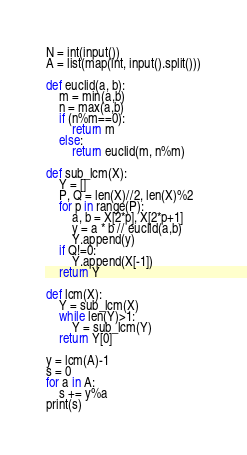Convert code to text. <code><loc_0><loc_0><loc_500><loc_500><_Python_>N = int(input())
A = list(map(int, input().split()))

def euclid(a, b):
    m = min(a,b)
    n = max(a,b)
    if (n%m==0):
        return m
    else:
        return euclid(m, n%m)

def sub_lcm(X):
    Y = []
    P, Q = len(X)//2, len(X)%2
    for p in range(P):
        a, b = X[2*p], X[2*p+1]
        y = a * b // euclid(a,b)
        Y.append(y)
    if Q!=0:
        Y.append(X[-1])
    return Y

def lcm(X):
    Y = sub_lcm(X)
    while len(Y)>1:
        Y = sub_lcm(Y)
    return Y[0]

y = lcm(A)-1
s = 0
for a in A:
    s += y%a
print(s)
</code> 